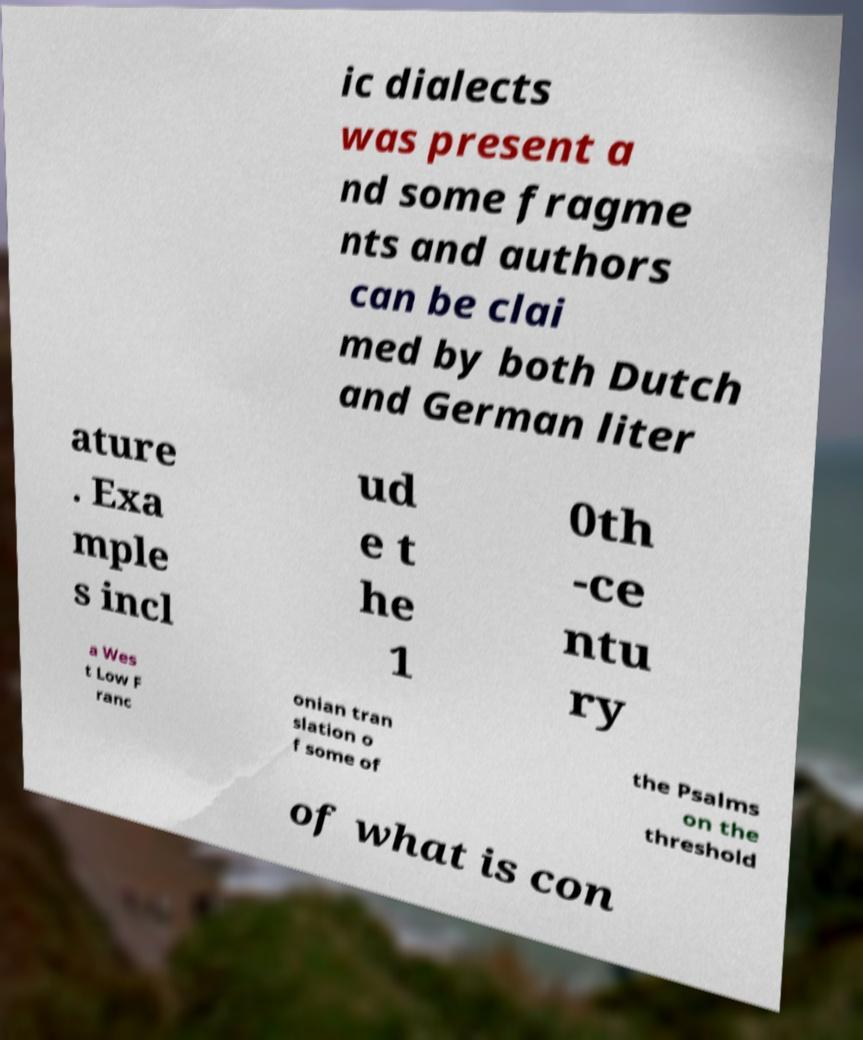Can you accurately transcribe the text from the provided image for me? ic dialects was present a nd some fragme nts and authors can be clai med by both Dutch and German liter ature . Exa mple s incl ud e t he 1 0th -ce ntu ry a Wes t Low F ranc onian tran slation o f some of the Psalms on the threshold of what is con 